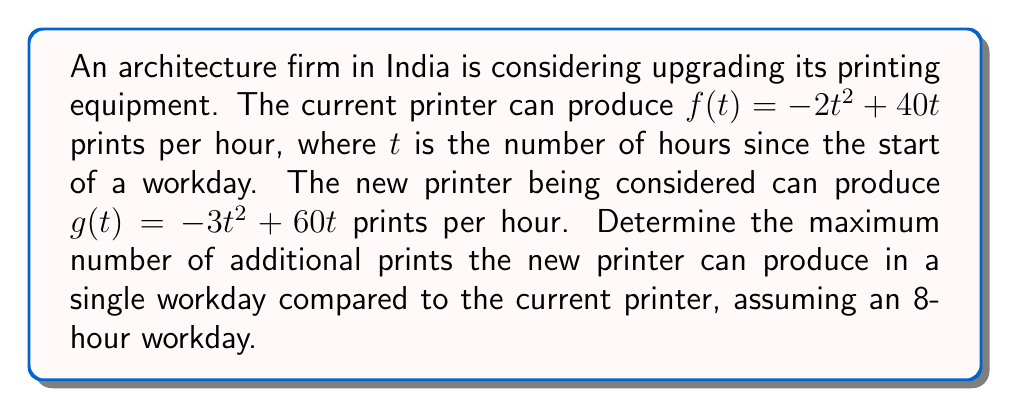Teach me how to tackle this problem. To solve this problem, we need to follow these steps:

1) Find the maximum number of prints for each printer:
   a) For the current printer: $f(t) = -2t^2 + 40t$
      $f'(t) = -4t + 40$
      Set $f'(t) = 0$: $-4t + 40 = 0$, $t = 10$
      The maximum occurs at $t = 10$ hours, but the workday is only 8 hours long.
      So, the maximum occurs at $t = 8$ for the 8-hour workday.

   b) For the new printer: $g(t) = -3t^2 + 60t$
      $g'(t) = -6t + 60$
      Set $g'(t) = 0$: $-6t + 60 = 0$, $t = 10$
      Again, the maximum occurs at $t = 10$ hours, but we use $t = 8$ for the 8-hour workday.

2) Calculate the total prints for each printer over 8 hours:
   a) Current printer: 
      $\int_0^8 f(t) dt = \int_0^8 (-2t^2 + 40t) dt$
      $= [-\frac{2}{3}t^3 + 20t^2]_0^8$
      $= (-\frac{2}{3}(512) + 20(64)) - 0 = 939.33$ prints

   b) New printer:
      $\int_0^8 g(t) dt = \int_0^8 (-3t^2 + 60t) dt$
      $= [-t^3 + 30t^2]_0^8$
      $= (-(512) + 30(64)) - 0 = 1408$ prints

3) Calculate the difference:
   $1408 - 939.33 = 468.67$ additional prints

Therefore, the new printer can produce approximately 469 additional prints in a single 8-hour workday.
Answer: 469 prints 